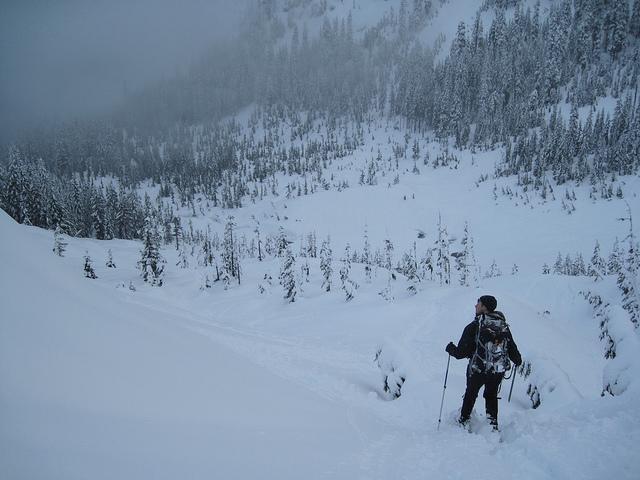How many people can you see?
Give a very brief answer. 1. 